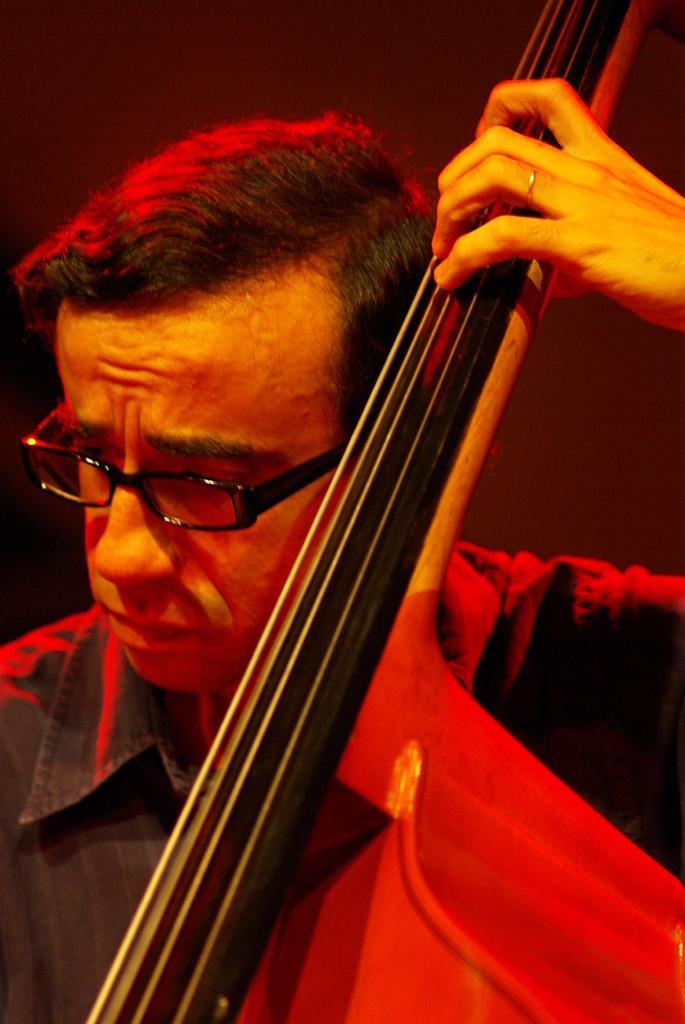Describe this image in one or two sentences. In the picture I can see a man is playing a musical instrument. The man is wearing spectacles and a shirt. 